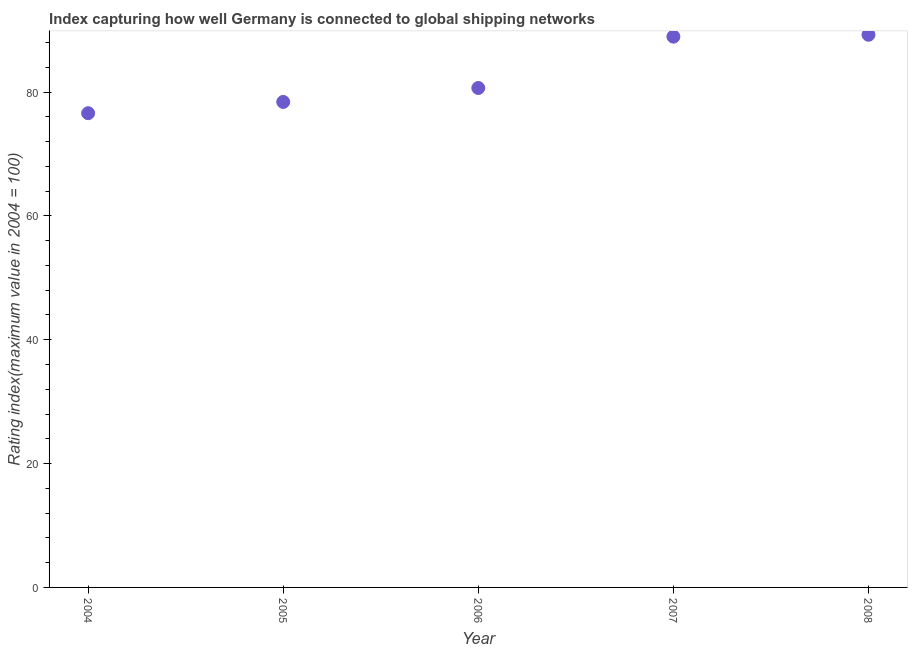What is the liner shipping connectivity index in 2004?
Offer a terse response. 76.59. Across all years, what is the maximum liner shipping connectivity index?
Give a very brief answer. 89.26. Across all years, what is the minimum liner shipping connectivity index?
Provide a short and direct response. 76.59. In which year was the liner shipping connectivity index minimum?
Offer a terse response. 2004. What is the sum of the liner shipping connectivity index?
Give a very brief answer. 413.87. What is the difference between the liner shipping connectivity index in 2004 and 2005?
Your answer should be very brief. -1.82. What is the average liner shipping connectivity index per year?
Make the answer very short. 82.77. What is the median liner shipping connectivity index?
Keep it short and to the point. 80.66. What is the ratio of the liner shipping connectivity index in 2007 to that in 2008?
Offer a terse response. 1. Is the liner shipping connectivity index in 2005 less than that in 2006?
Your response must be concise. Yes. Is the difference between the liner shipping connectivity index in 2005 and 2006 greater than the difference between any two years?
Provide a succinct answer. No. What is the difference between the highest and the second highest liner shipping connectivity index?
Ensure brevity in your answer.  0.31. Is the sum of the liner shipping connectivity index in 2004 and 2008 greater than the maximum liner shipping connectivity index across all years?
Offer a very short reply. Yes. What is the difference between the highest and the lowest liner shipping connectivity index?
Provide a short and direct response. 12.67. In how many years, is the liner shipping connectivity index greater than the average liner shipping connectivity index taken over all years?
Make the answer very short. 2. How many years are there in the graph?
Offer a very short reply. 5. Does the graph contain grids?
Your answer should be very brief. No. What is the title of the graph?
Provide a succinct answer. Index capturing how well Germany is connected to global shipping networks. What is the label or title of the X-axis?
Provide a succinct answer. Year. What is the label or title of the Y-axis?
Keep it short and to the point. Rating index(maximum value in 2004 = 100). What is the Rating index(maximum value in 2004 = 100) in 2004?
Offer a very short reply. 76.59. What is the Rating index(maximum value in 2004 = 100) in 2005?
Your response must be concise. 78.41. What is the Rating index(maximum value in 2004 = 100) in 2006?
Ensure brevity in your answer.  80.66. What is the Rating index(maximum value in 2004 = 100) in 2007?
Keep it short and to the point. 88.95. What is the Rating index(maximum value in 2004 = 100) in 2008?
Your answer should be compact. 89.26. What is the difference between the Rating index(maximum value in 2004 = 100) in 2004 and 2005?
Ensure brevity in your answer.  -1.82. What is the difference between the Rating index(maximum value in 2004 = 100) in 2004 and 2006?
Provide a succinct answer. -4.07. What is the difference between the Rating index(maximum value in 2004 = 100) in 2004 and 2007?
Make the answer very short. -12.36. What is the difference between the Rating index(maximum value in 2004 = 100) in 2004 and 2008?
Keep it short and to the point. -12.67. What is the difference between the Rating index(maximum value in 2004 = 100) in 2005 and 2006?
Ensure brevity in your answer.  -2.25. What is the difference between the Rating index(maximum value in 2004 = 100) in 2005 and 2007?
Your response must be concise. -10.54. What is the difference between the Rating index(maximum value in 2004 = 100) in 2005 and 2008?
Offer a very short reply. -10.85. What is the difference between the Rating index(maximum value in 2004 = 100) in 2006 and 2007?
Your response must be concise. -8.29. What is the difference between the Rating index(maximum value in 2004 = 100) in 2006 and 2008?
Keep it short and to the point. -8.6. What is the difference between the Rating index(maximum value in 2004 = 100) in 2007 and 2008?
Make the answer very short. -0.31. What is the ratio of the Rating index(maximum value in 2004 = 100) in 2004 to that in 2006?
Offer a very short reply. 0.95. What is the ratio of the Rating index(maximum value in 2004 = 100) in 2004 to that in 2007?
Your answer should be very brief. 0.86. What is the ratio of the Rating index(maximum value in 2004 = 100) in 2004 to that in 2008?
Ensure brevity in your answer.  0.86. What is the ratio of the Rating index(maximum value in 2004 = 100) in 2005 to that in 2007?
Your answer should be compact. 0.88. What is the ratio of the Rating index(maximum value in 2004 = 100) in 2005 to that in 2008?
Your answer should be very brief. 0.88. What is the ratio of the Rating index(maximum value in 2004 = 100) in 2006 to that in 2007?
Your answer should be compact. 0.91. What is the ratio of the Rating index(maximum value in 2004 = 100) in 2006 to that in 2008?
Your response must be concise. 0.9. What is the ratio of the Rating index(maximum value in 2004 = 100) in 2007 to that in 2008?
Give a very brief answer. 1. 